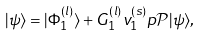<formula> <loc_0><loc_0><loc_500><loc_500>| \psi \rangle = | \Phi _ { 1 } ^ { ( l ) } \rangle + G _ { 1 } ^ { ( l ) } v _ { 1 } ^ { ( s ) } p { \mathcal { P } } | \psi \rangle ,</formula> 